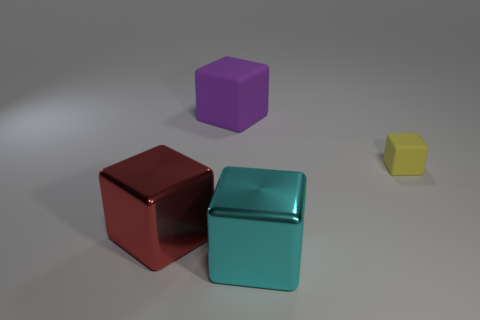Do the rubber cube that is behind the yellow thing and the small object have the same size?
Your answer should be very brief. No. Are there fewer shiny blocks than big cubes?
Provide a succinct answer. Yes. Is there another block made of the same material as the small yellow block?
Ensure brevity in your answer.  Yes. What shape is the big object behind the red metallic thing?
Make the answer very short. Cube. Are there fewer matte blocks that are in front of the purple matte block than big blocks?
Your response must be concise. Yes. There is a tiny object that is the same material as the large purple block; what is its color?
Make the answer very short. Yellow. What size is the matte object on the right side of the big cyan cube?
Ensure brevity in your answer.  Small. Does the cyan object have the same material as the big red thing?
Ensure brevity in your answer.  Yes. There is a thing that is to the left of the matte block behind the small rubber cube; are there any shiny objects that are right of it?
Your response must be concise. Yes. The tiny object is what color?
Make the answer very short. Yellow. 